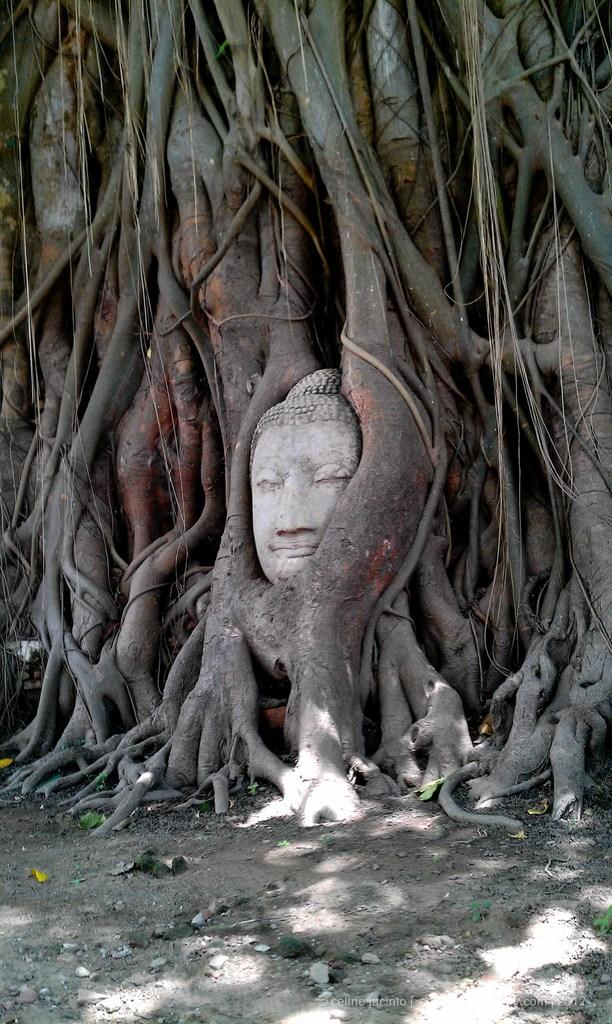What type of plant can be seen in the image? There is a tree in the image. What is the main object in the center of the image? There is a sculpture in the center of the image. What is located at the bottom of the image? There is a walkway, sand, and some scrap at the bottom of the image. What sign can be seen at the edge of the image? There is no sign present in the image; it only features a tree, a sculpture, a walkway, sand, and some scrap. 